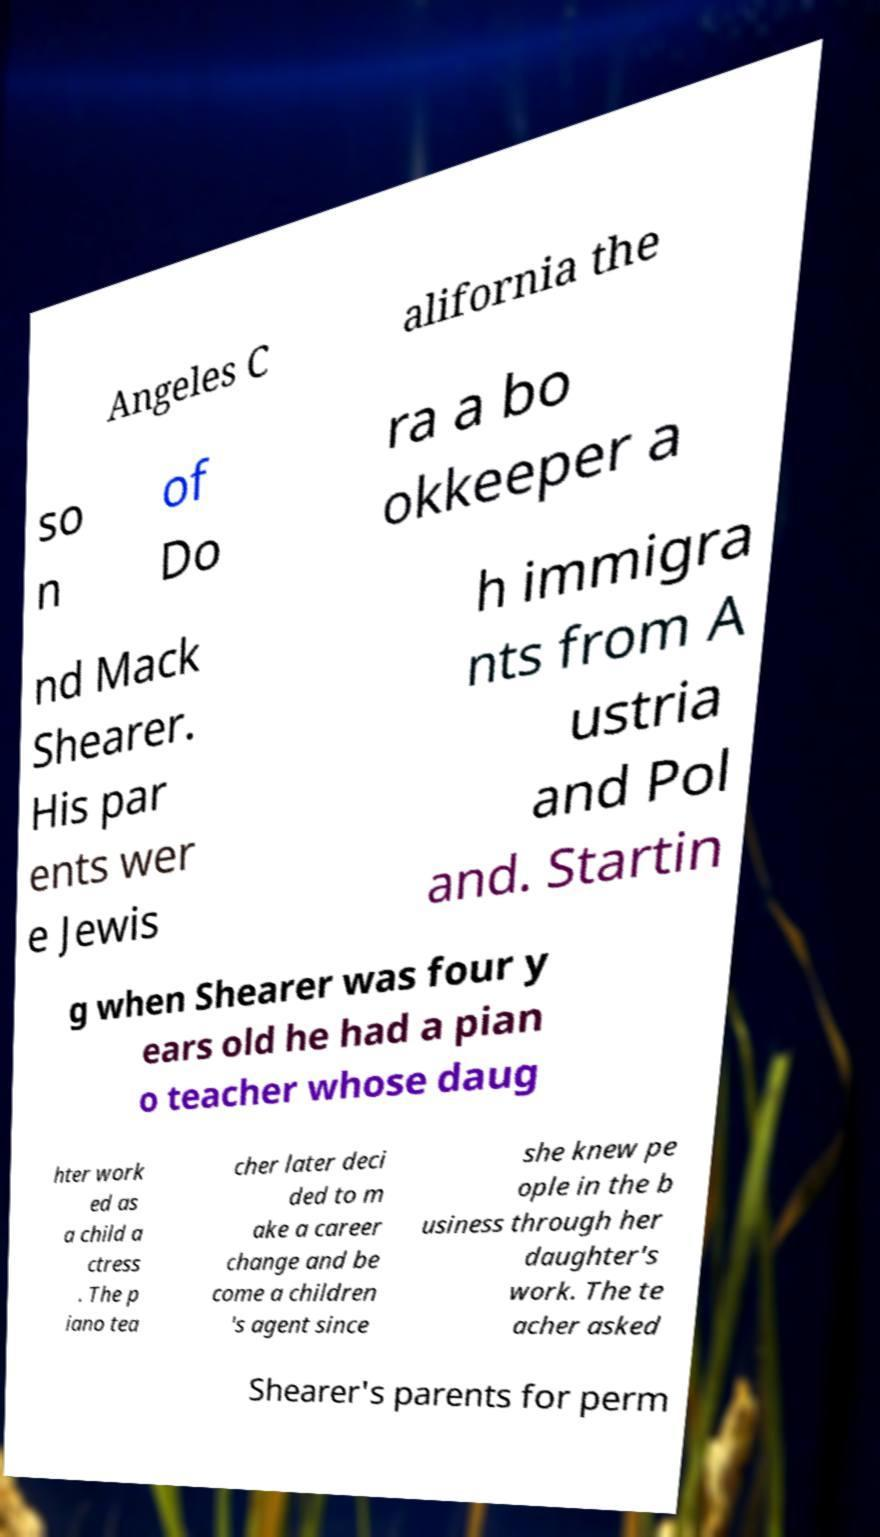For documentation purposes, I need the text within this image transcribed. Could you provide that? Angeles C alifornia the so n of Do ra a bo okkeeper a nd Mack Shearer. His par ents wer e Jewis h immigra nts from A ustria and Pol and. Startin g when Shearer was four y ears old he had a pian o teacher whose daug hter work ed as a child a ctress . The p iano tea cher later deci ded to m ake a career change and be come a children 's agent since she knew pe ople in the b usiness through her daughter's work. The te acher asked Shearer's parents for perm 